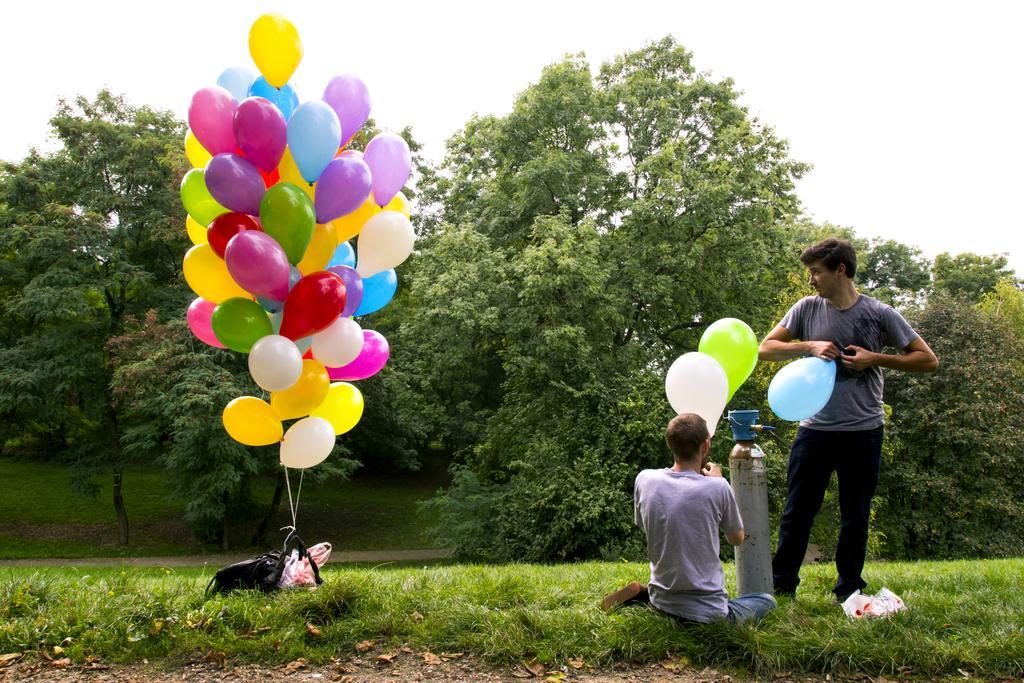Could you give a brief overview of what you see in this image? In this picture we can see 2 people on the grass holding balloons. On the left side, we can see a bunch of balloons. In the background, we can see many trees. 